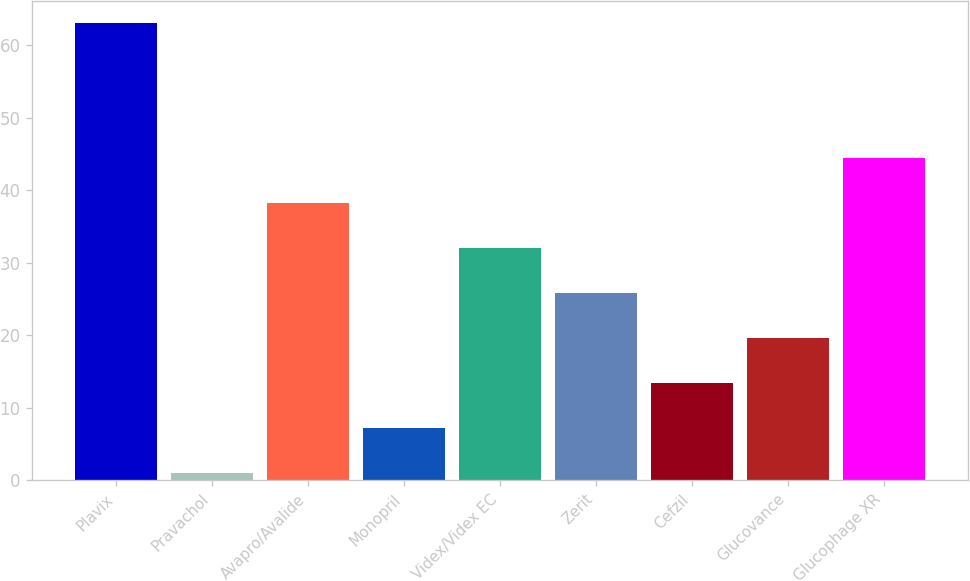<chart> <loc_0><loc_0><loc_500><loc_500><bar_chart><fcel>Plavix<fcel>Pravachol<fcel>Avapro/Avalide<fcel>Monopril<fcel>Videx/Videx EC<fcel>Zerit<fcel>Cefzil<fcel>Glucovance<fcel>Glucophage XR<nl><fcel>63<fcel>1<fcel>38.2<fcel>7.2<fcel>32<fcel>25.8<fcel>13.4<fcel>19.6<fcel>44.4<nl></chart> 